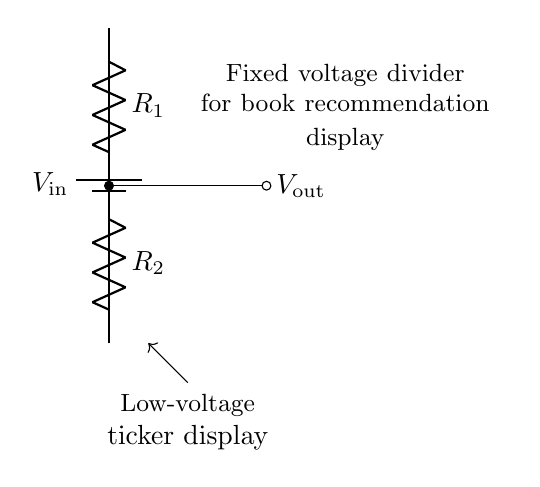What is the type of battery used in this circuit? The circuit diagram shows a "battery1" component which indicates a fixed voltage source typically used for circuits requiring a steady voltage supply.
Answer: Battery What does the component R1 represent? In the circuit, R1 is labeled as a resistor and acts as part of the voltage divider, determining how much voltage is dropped across it compared to the total input voltage.
Answer: Resistor What is the output voltage? The output voltage, labeled as Vout, is taken from the junction between R1 and R2, which is a characteristic of voltage dividers where the voltage is divided proportionally to the resistors.
Answer: Vout How many resistors are in this circuit? The circuit diagram clearly shows two resistors, R1 and R2, which work together in the voltage divider configuration to create the desired output voltage from the input voltage.
Answer: Two What is the purpose of the fixed voltage divider? The fixed voltage divider is specifically designed to provide a low voltage suitable for powering the ticker display, illustrating its role in reducing the voltage from the input to a level appropriate for the application.
Answer: To power the ticker display What is the load connected to this circuit? The load in this circuit is indicated as a "Low-voltage ticker display" which signifies that the output voltage is intended to drive this specific display device.
Answer: Ticker display What type of circuit is represented by this diagram? This circuit is a voltage divider, a specific type of passive electrical circuit that uses two resistors to divide a voltage input into a smaller voltage output.
Answer: Voltage divider 